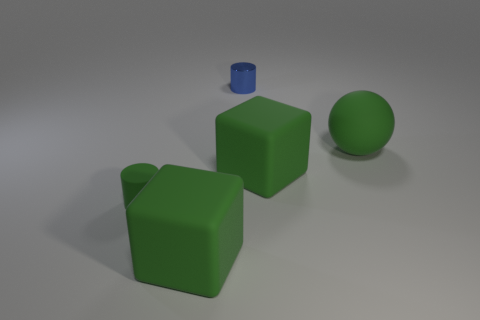Subtract all green cubes. How many were subtracted if there are1green cubes left? 1 Add 3 large green matte balls. How many objects exist? 8 Subtract all spheres. How many objects are left? 4 Subtract all tiny cyan shiny cylinders. Subtract all metallic objects. How many objects are left? 4 Add 2 green spheres. How many green spheres are left? 3 Add 4 green cylinders. How many green cylinders exist? 5 Subtract 0 purple blocks. How many objects are left? 5 